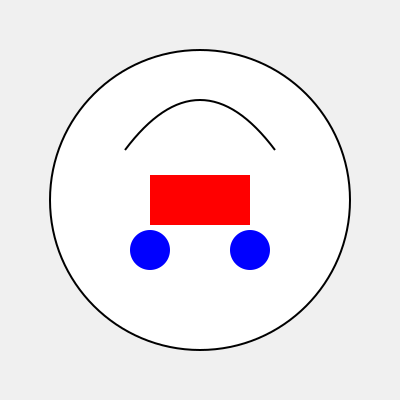Which visual novel character is represented by this iconic combination of accessories: a red scarf, blue earrings, and a distinct hairstyle with curved bangs? To identify the visual novel character based on these signature accessories and clothing items, let's break down the elements:

1. Red scarf: The large red rectangle in the middle of the image represents a prominent red scarf.
2. Blue earrings: The two blue circles at the bottom of the face outline indicate blue earrings.
3. Curved bangs: The curved line at the top of the head represents a distinct hairstyle with curved bangs.

These elements are iconic features of Ryougi Shiki, the protagonist from the visual novel "Kara no Kyoukai" (The Garden of Sinners). Shiki is known for her:

- Red leather jacket or scarf, which is her signature outerwear
- Blue gem earrings, which are a constant accessory
- Distinct hairstyle with curved bangs that frame her face

The combination of these three elements is uniquely associated with Ryougi Shiki in the visual novel world, making her instantly recognizable to fans of the series.
Answer: Ryougi Shiki 